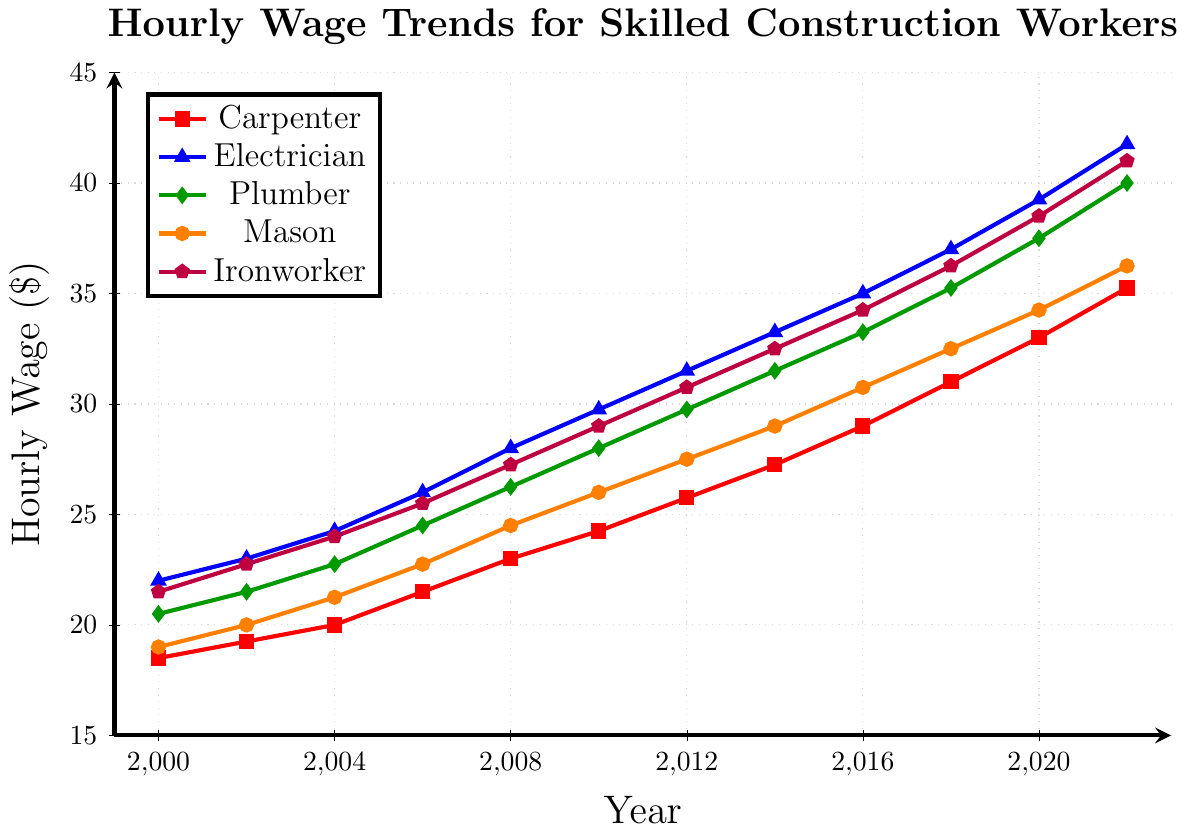Which trade had the highest hourly wage in 2022? Look at the figure and identify the trade line that reaches the highest point on the y-axis in 2022, which is the blue line for Electrician at $41.75.
Answer: Electrician What was the wage difference between an Electrician and a Mason in 2010? Find the hourly wage for both trades in 2010 from the figure; Electrician: $29.75, Mason: $26.00, then subtract them: $29.75 - $26.00
Answer: $3.75 Which trade showed the most consistent wage increase over the years? Compare the smoothness and steadiness of the lines; the Carpenter's red line shows the most consistent year-over-year increase without fluctuations.
Answer: Carpenter In which year did the wage for Plumbers surpass $30 for the first time? Look for the first occurrence of the green line for Plumber crossing the $30 mark on the y-axis; this happened in 2014.
Answer: 2014 By how much did the hourly wage for Ironworkers increase from 2000 to 2022? Subtract the hourly wage for Ironworkers in 2000 from their wage in 2022: $41.00 - $21.50
Answer: $19.50 Which trades had hourly wages above $35 in 2020? Look at the hourly wages for all trades in 2020 and identify those above $35: Electrician ($39.25), Plumber ($37.50), Ironworker ($38.50)
Answer: Electrician, Plumber, Ironworker In which year was the gap between the wages of Carpenters and Ironworkers the smallest? Compare the distance between the red and purple lines on the figure and find the year where this distance is minimal. In 2000, the difference was smallest: $21.50 - $18.50 = $3.00.
Answer: 2000 What visual trend is evident for the hourly wages of all trades from 2000 to 2022? All trade lines (red, blue, green, orange, purple) are rising, indicating an upward trend in hourly wages across the board.
Answer: Upward trend Estimate the average hourly wage for Masons over the period 2000-2022. Add up all yearly wages for Masons from the figure and divide by the number of years: (19.00 + 20.00 + 21.25 + 22.75 + 24.50 + 26.00 + 27.50 + 29.00 + 30.75 + 32.50 + 34.25 + 36.25) / 12 = 27.15
Answer: $27.15 